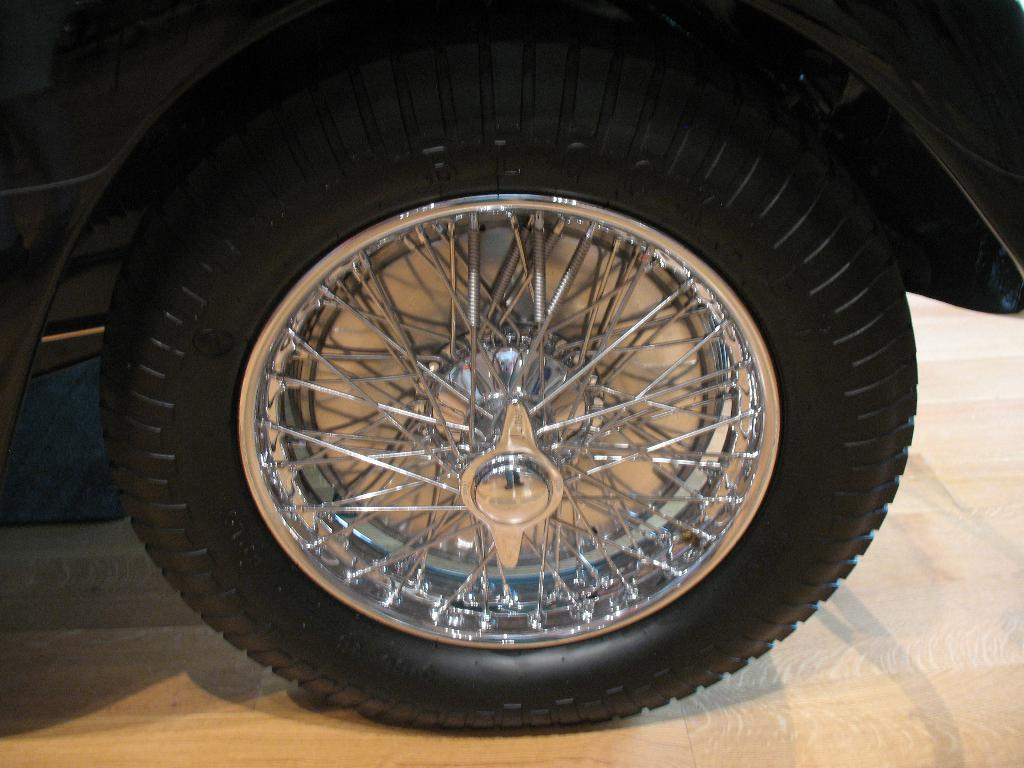What is the main subject of the image? The main subject of the image is a wheel of a vehicle. What can be observed about the path in the image? The path in the image is of brown color. How many chickens can be seen in the image? There are no chickens present in the image. What type of skin is visible on the girl in the image? There is no girl present in the image. 